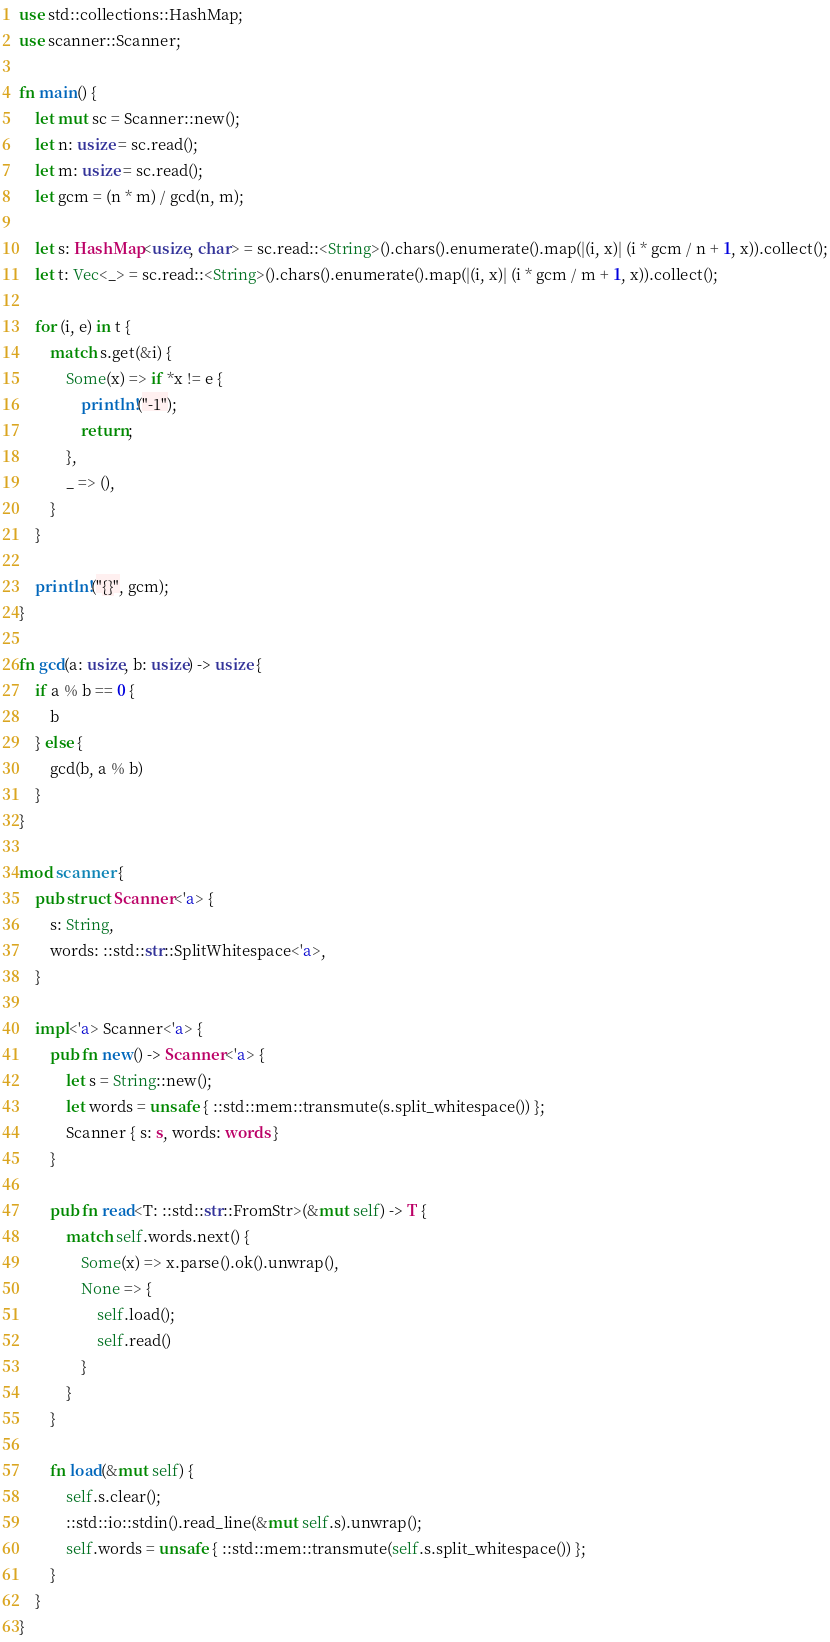Convert code to text. <code><loc_0><loc_0><loc_500><loc_500><_Rust_>use std::collections::HashMap;
use scanner::Scanner;

fn main() {
    let mut sc = Scanner::new();
    let n: usize = sc.read();
    let m: usize = sc.read();
    let gcm = (n * m) / gcd(n, m);

    let s: HashMap<usize, char> = sc.read::<String>().chars().enumerate().map(|(i, x)| (i * gcm / n + 1, x)).collect();
    let t: Vec<_> = sc.read::<String>().chars().enumerate().map(|(i, x)| (i * gcm / m + 1, x)).collect();

    for (i, e) in t {
        match s.get(&i) {
            Some(x) => if *x != e {
                println!("-1");
                return;
            },
            _ => (),
        }
    }

    println!("{}", gcm);
}

fn gcd(a: usize, b: usize) -> usize {
    if a % b == 0 {
        b
    } else {
        gcd(b, a % b)
    }
}

mod scanner {
    pub struct Scanner<'a> {
        s: String,
        words: ::std::str::SplitWhitespace<'a>,
    }

    impl<'a> Scanner<'a> {
        pub fn new() -> Scanner<'a> {
            let s = String::new();
            let words = unsafe { ::std::mem::transmute(s.split_whitespace()) };
            Scanner { s: s, words: words }
        }

        pub fn read<T: ::std::str::FromStr>(&mut self) -> T {
            match self.words.next() {
                Some(x) => x.parse().ok().unwrap(),
                None => {
                    self.load();
                    self.read()
                }
            }
        }

        fn load(&mut self) {
            self.s.clear();
            ::std::io::stdin().read_line(&mut self.s).unwrap();
            self.words = unsafe { ::std::mem::transmute(self.s.split_whitespace()) };
        }
    }
}
</code> 